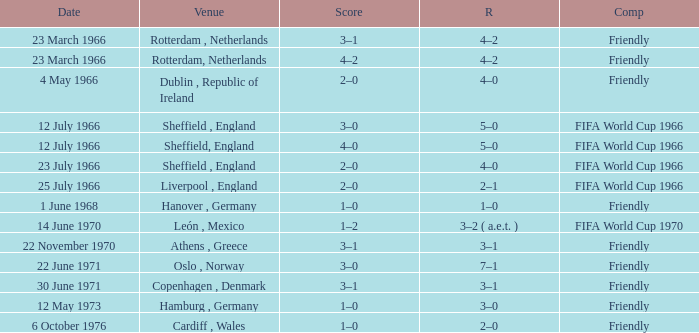Which result's venue was in Rotterdam, Netherlands? 4–2, 4–2. 